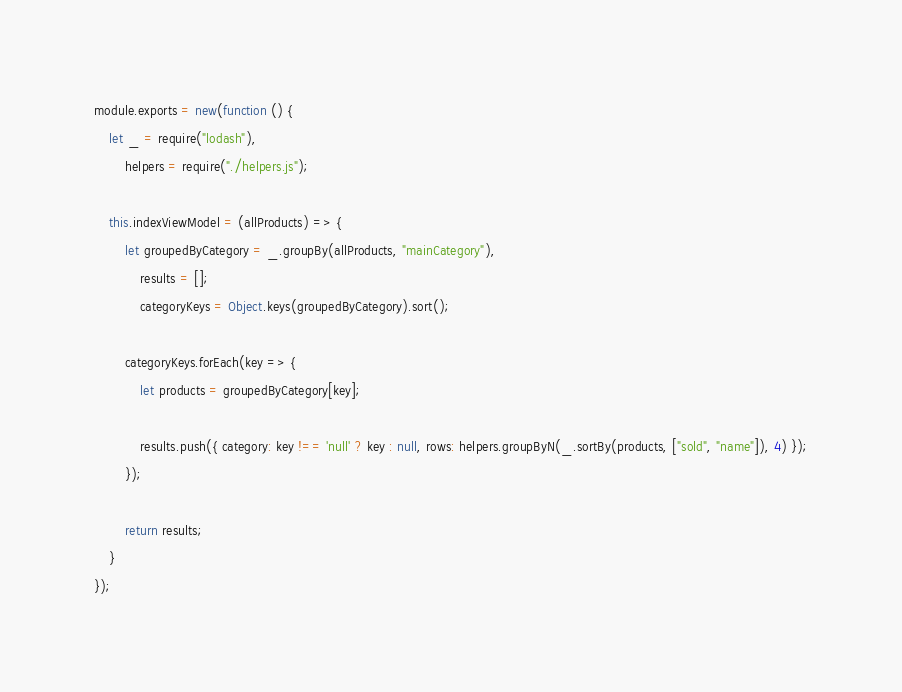Convert code to text. <code><loc_0><loc_0><loc_500><loc_500><_JavaScript_>module.exports = new(function () {
    let _ = require("lodash"),
        helpers = require("./helpers.js");

    this.indexViewModel = (allProducts) => {
        let groupedByCategory = _.groupBy(allProducts, "mainCategory"),
            results = [];
            categoryKeys = Object.keys(groupedByCategory).sort();

        categoryKeys.forEach(key => {
            let products = groupedByCategory[key];

            results.push({ category: key !== 'null' ? key : null, rows: helpers.groupByN(_.sortBy(products, ["sold", "name"]), 4) });
        });

        return results;
    }
});</code> 